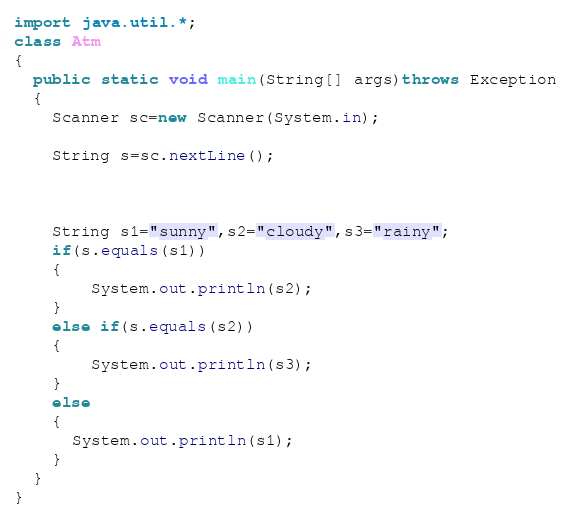Convert code to text. <code><loc_0><loc_0><loc_500><loc_500><_Java_>import java.util.*;
class Atm
{
  public static void main(String[] args)throws Exception
  {
    Scanner sc=new Scanner(System.in);
    
    String s=sc.nextLine();
    
   
    
    String s1="sunny",s2="cloudy",s3="rainy";
    if(s.equals(s1))
    {
    	System.out.println(s2);
    }
    else if(s.equals(s2))
    {
    	System.out.println(s3);
    }
    else
    {
      System.out.println(s1);
    }
  }
}</code> 